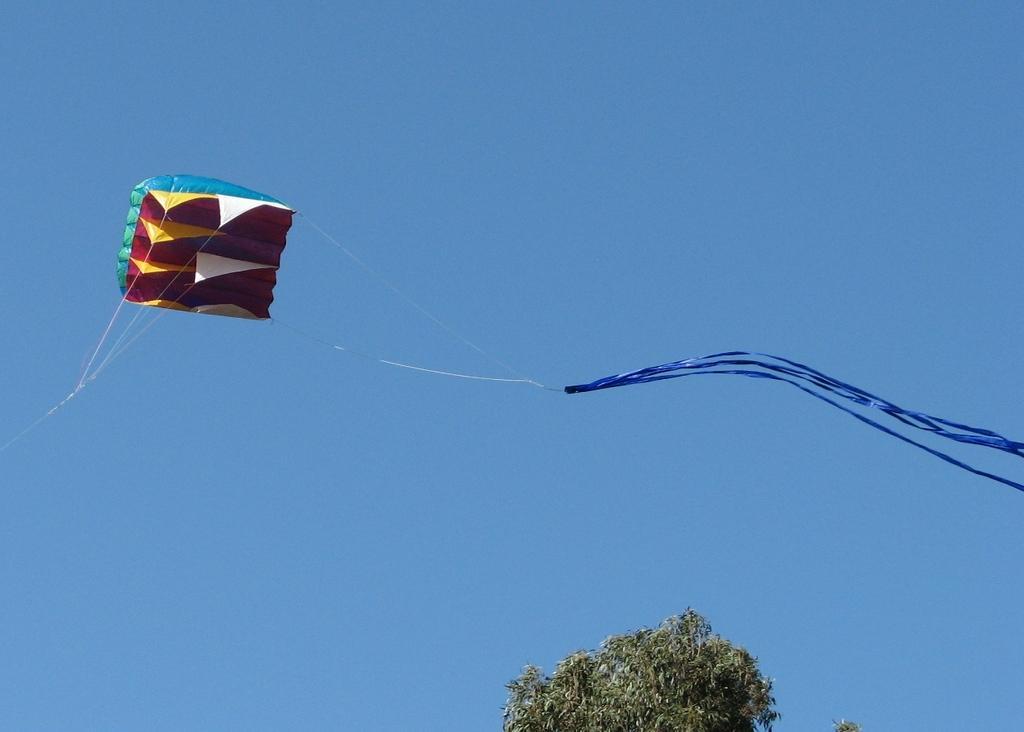How would you summarize this image in a sentence or two? Here in this picture we can see a kite flying in the air and we can also see a tree present in the bottom over there. 